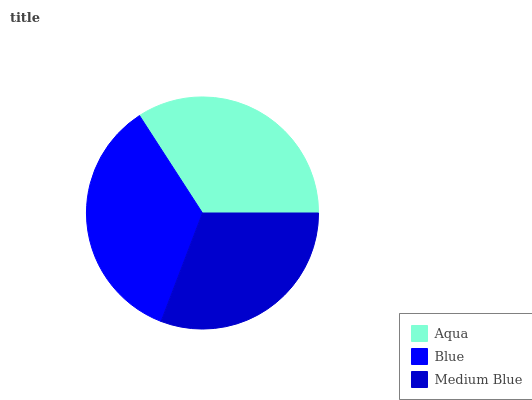Is Medium Blue the minimum?
Answer yes or no. Yes. Is Blue the maximum?
Answer yes or no. Yes. Is Blue the minimum?
Answer yes or no. No. Is Medium Blue the maximum?
Answer yes or no. No. Is Blue greater than Medium Blue?
Answer yes or no. Yes. Is Medium Blue less than Blue?
Answer yes or no. Yes. Is Medium Blue greater than Blue?
Answer yes or no. No. Is Blue less than Medium Blue?
Answer yes or no. No. Is Aqua the high median?
Answer yes or no. Yes. Is Aqua the low median?
Answer yes or no. Yes. Is Medium Blue the high median?
Answer yes or no. No. Is Blue the low median?
Answer yes or no. No. 